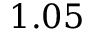<formula> <loc_0><loc_0><loc_500><loc_500>1 . 0 5</formula> 